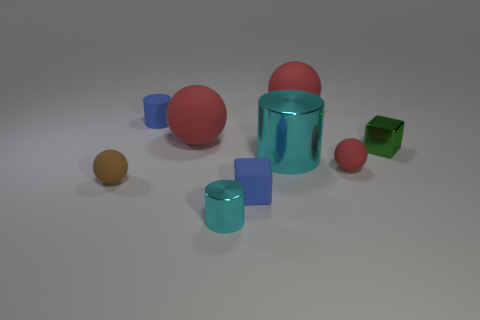How many red balls must be subtracted to get 1 red balls? 2 Subtract all brown cubes. How many red balls are left? 3 Subtract all balls. How many objects are left? 5 Add 9 green things. How many green things are left? 10 Add 1 tiny green metallic things. How many tiny green metallic things exist? 2 Subtract 0 green cylinders. How many objects are left? 9 Subtract all small purple matte cylinders. Subtract all metal things. How many objects are left? 6 